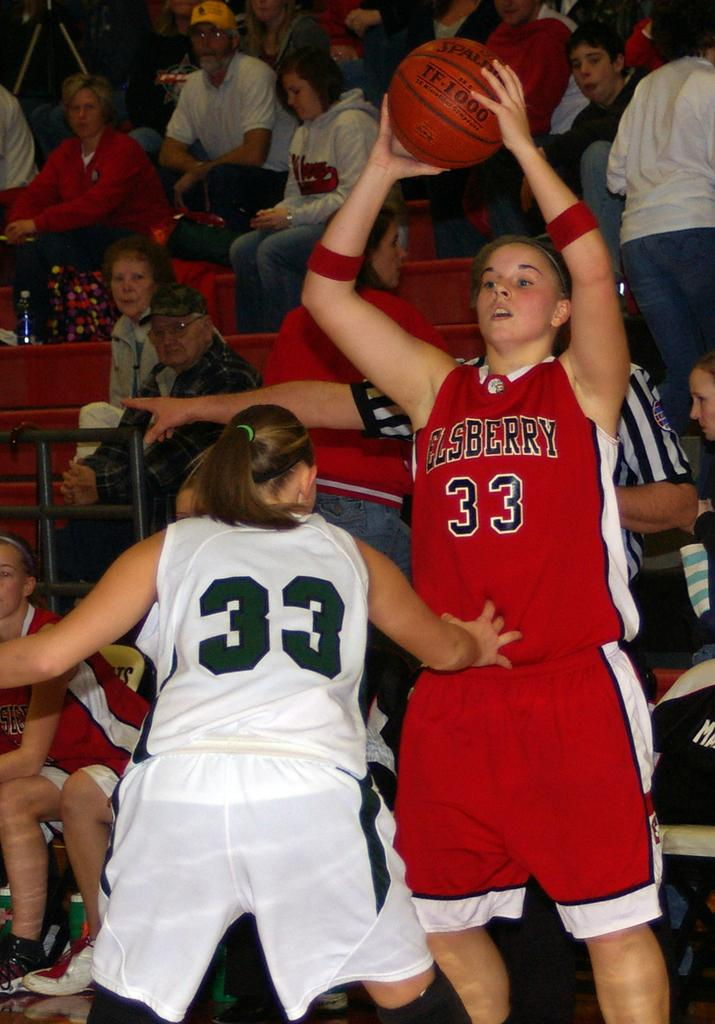<image>
Summarize the visual content of the image. A blonde female basketball player wearing an Elsberry 33 jersey shoots the ball. 